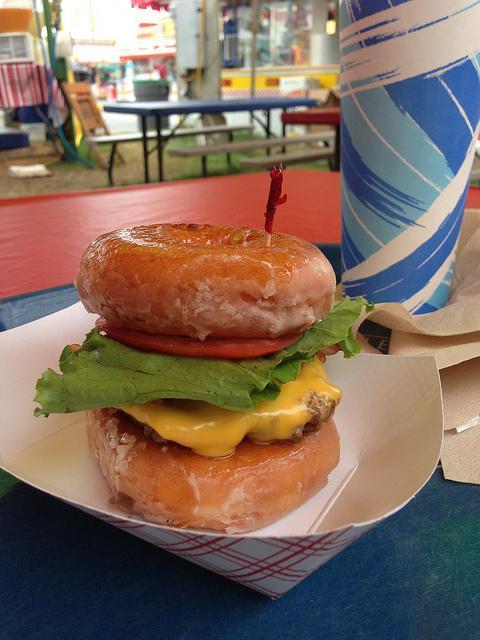How many bowls are in the picture?
Give a very brief answer. 1. How many benches are in the photo?
Give a very brief answer. 2. How many people are facing left?
Give a very brief answer. 0. 